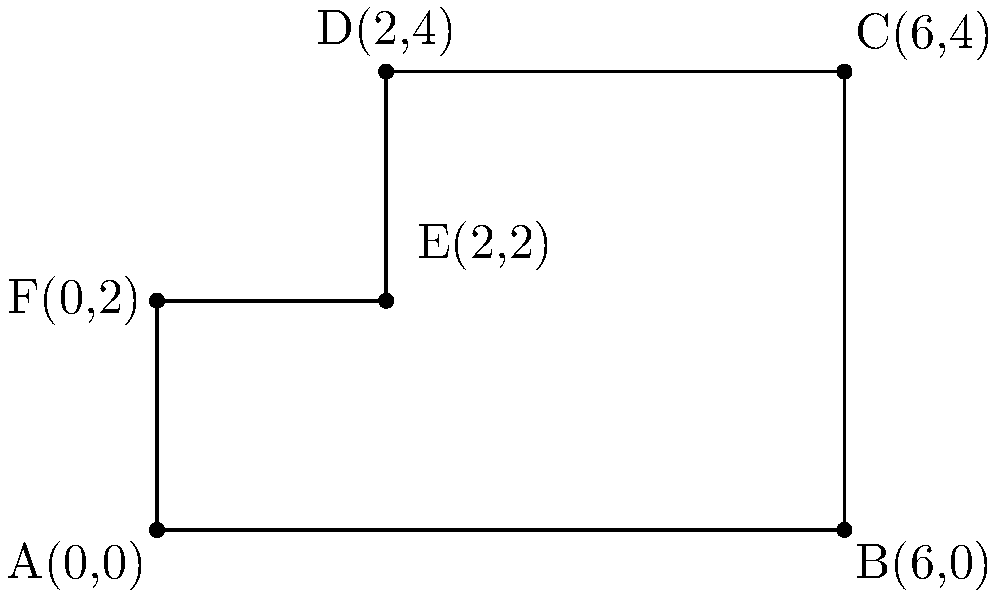In your secret garden, you've decided to create a unique enclosed area using straight fences. The corners of this area are represented by the following coordinates: A(0,0), B(6,0), C(6,4), D(2,4), E(2,2), and F(0,2). Using your knowledge of coordinate geometry, can you determine the area of this secret garden? Let's approach this step-by-step:

1) We can divide the shape into three rectangles:
   Rectangle 1: ABCF
   Rectangle 2: DEFC
   Rectangle 3: DEF

2) For Rectangle 1 (ABCF):
   Width = 6 - 0 = 6
   Height = 2 - 0 = 2
   Area of Rectangle 1 = $6 \times 2 = 12$ square units

3) For Rectangle 2 (DEFC):
   Width = 6 - 2 = 4
   Height = 4 - 2 = 2
   Area of Rectangle 2 = $4 \times 2 = 8$ square units

4) For Rectangle 3 (DEF):
   Width = 2 - 0 = 2
   Height = 4 - 2 = 2
   Area of Rectangle 3 = $2 \times 2 = 4$ square units

5) The total area is the sum of these three rectangles:
   Total Area = Area of Rectangle 1 + Area of Rectangle 2 + Area of Rectangle 3
               = $12 + 8 + 4 = 24$ square units

Therefore, the area of your secret garden is 24 square units.
Answer: 24 square units 